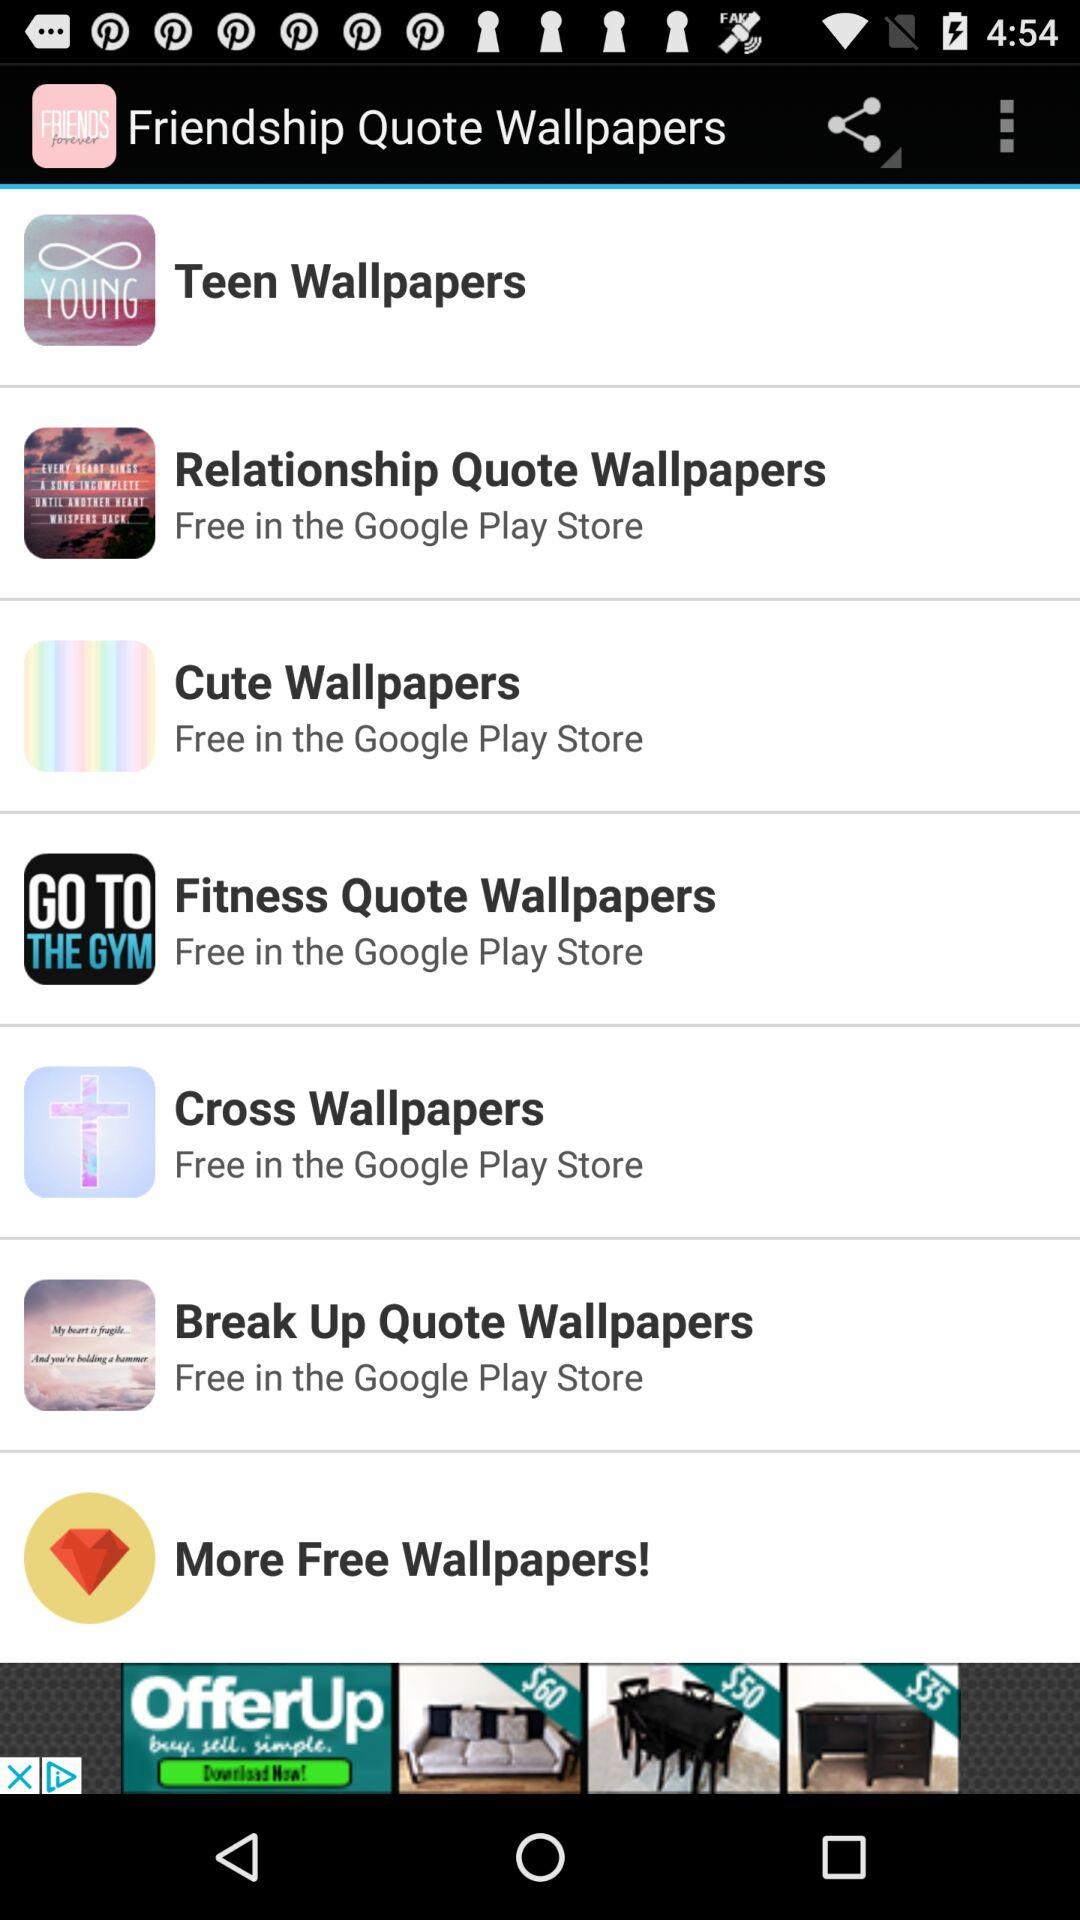How many wallpapers are free in the Google Play Store?
Answer the question using a single word or phrase. 6 